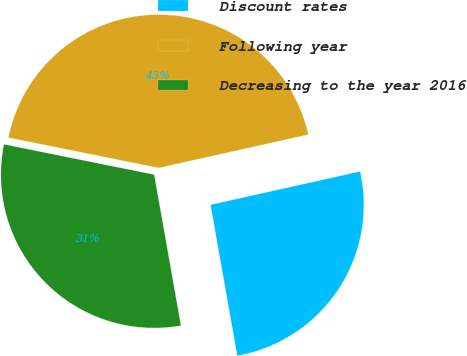Convert chart. <chart><loc_0><loc_0><loc_500><loc_500><pie_chart><fcel>Discount rates<fcel>Following year<fcel>Decreasing to the year 2016<nl><fcel>25.7%<fcel>43.34%<fcel>30.96%<nl></chart> 